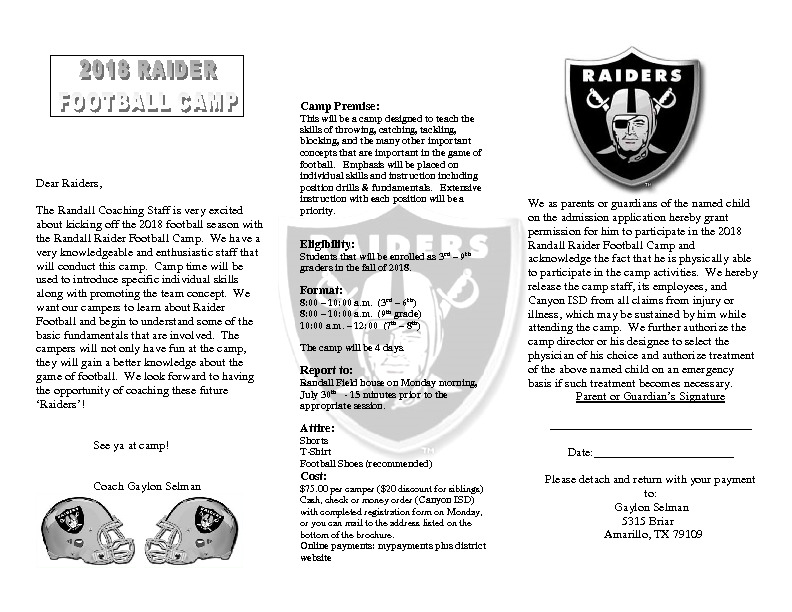What fun activities might a child experience at this football camp? Children attending this football camp might experience a variety of fun activities that help them learn the fundamentals of football in an engaging way. These could include skill drills that teach throwing, catching, and kicking techniques, fun mini-games that involve teamwork and strategy, and instructional sessions focusing on individual positions. They might also enjoy friendly scrimmages where they can practice what they've learned in a playful, non-competitive environment. The camp's approach aims to make learning football both educational and enjoyable! 